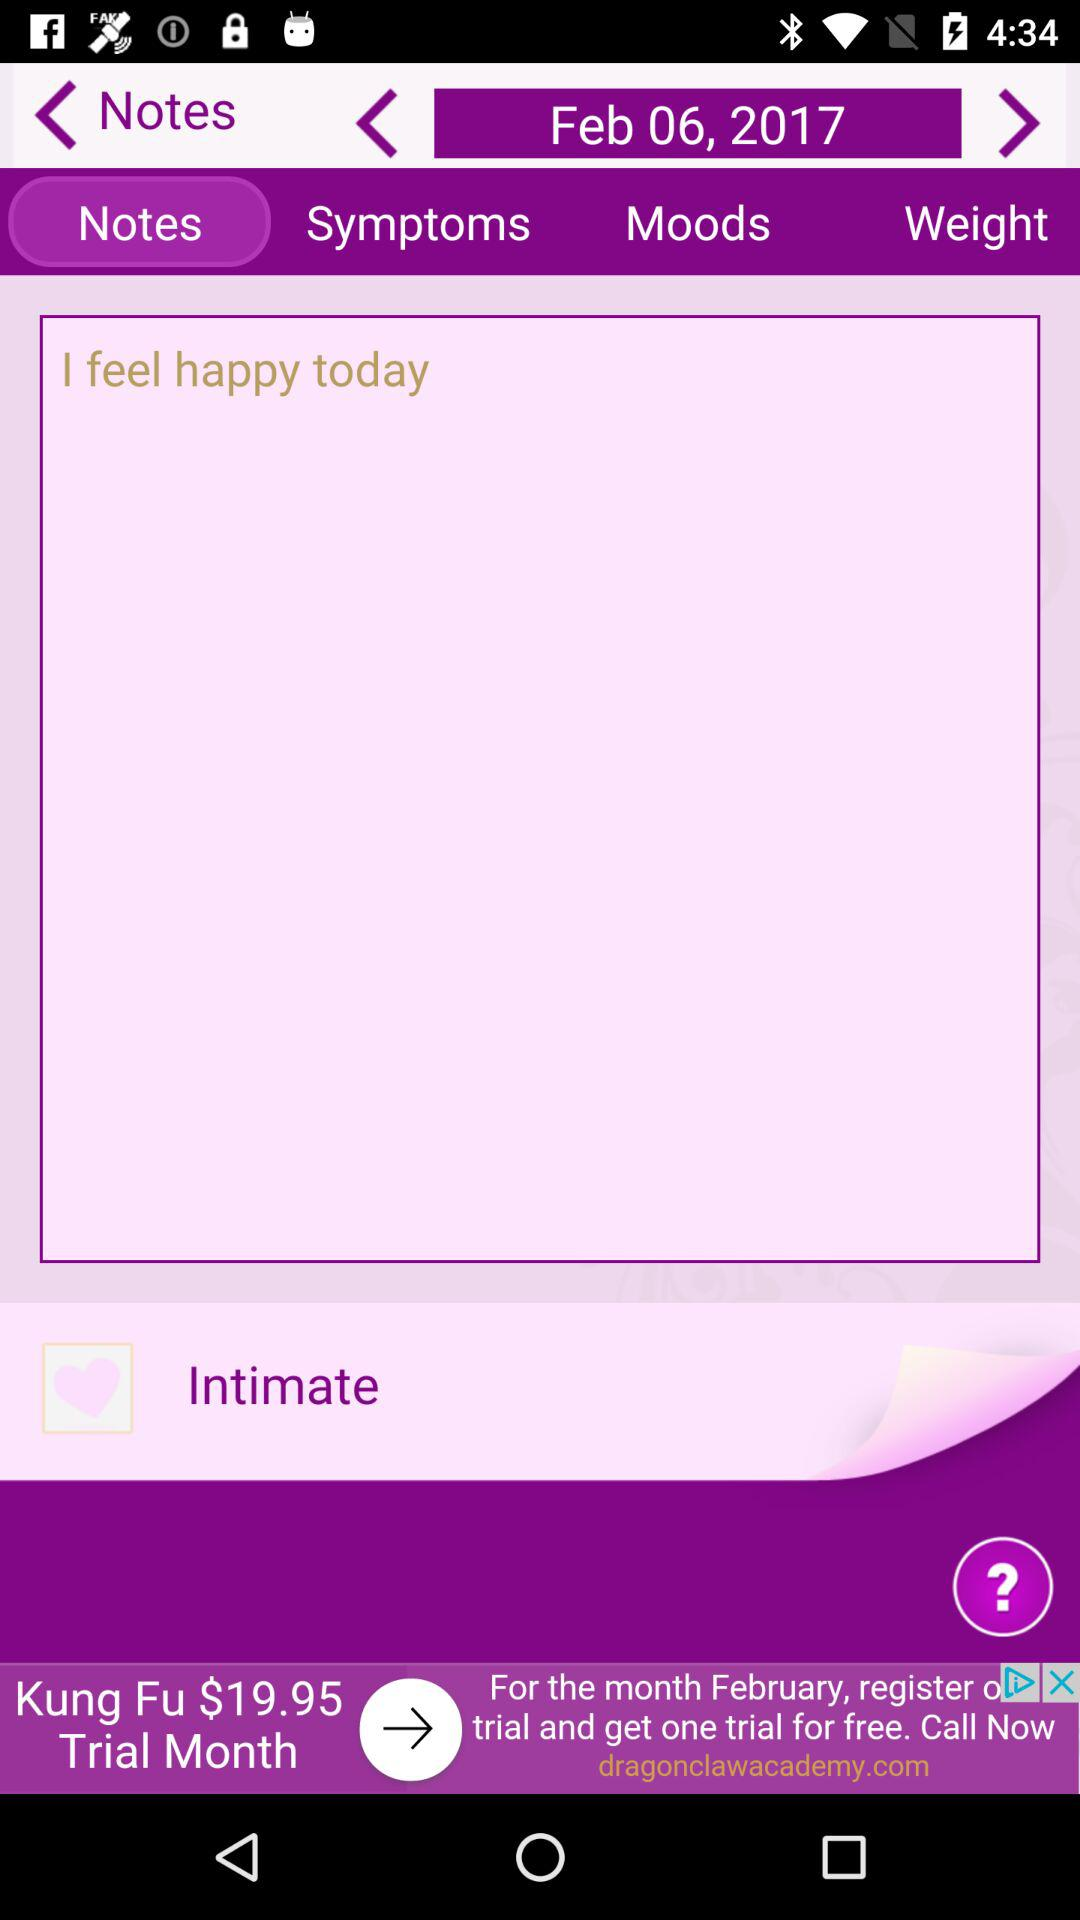What is the selected date? The selected date is February 6, 2017. 